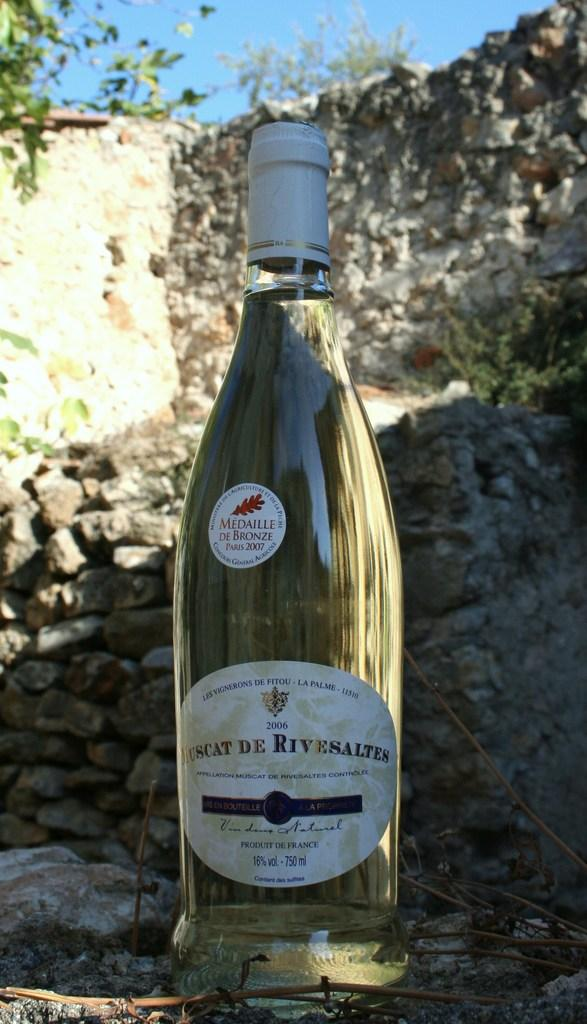<image>
Give a short and clear explanation of the subsequent image. Large bottle that says the year 2007 on the top. 